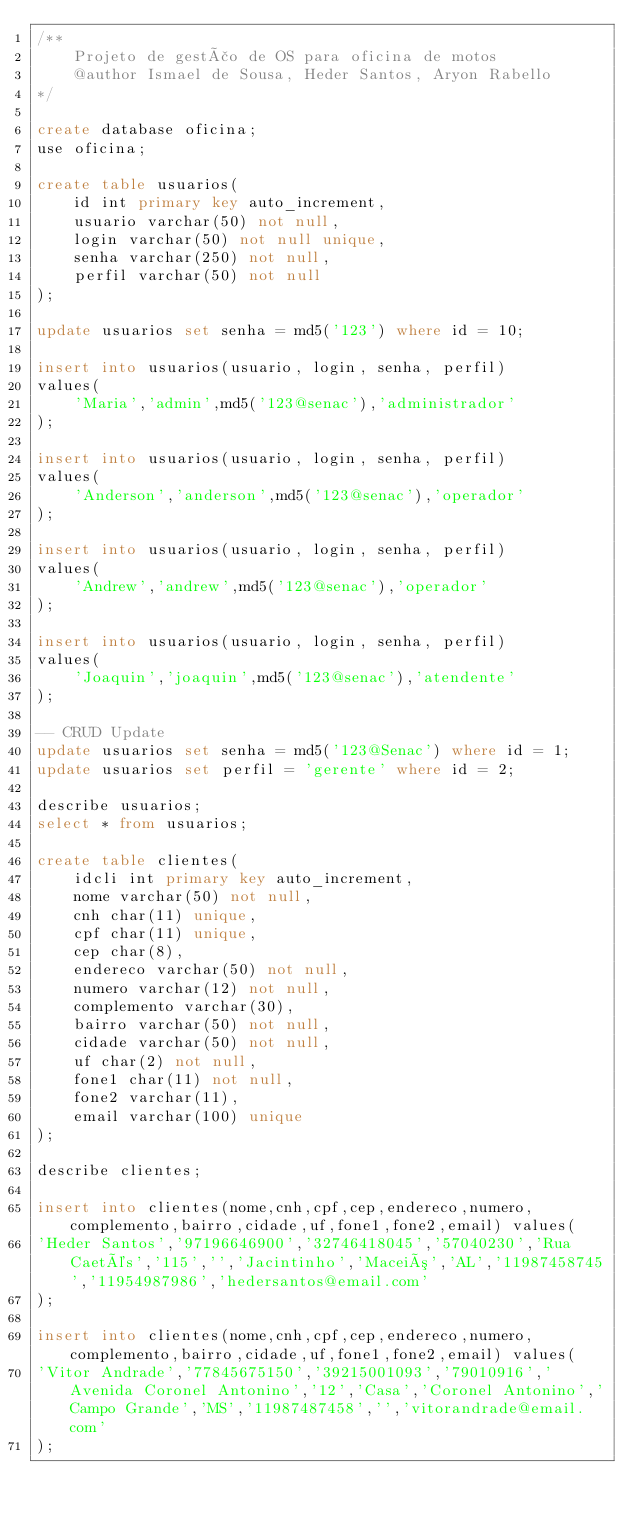Convert code to text. <code><loc_0><loc_0><loc_500><loc_500><_SQL_>/**
	Projeto de gestão de OS para oficina de motos
    @author Ismael de Sousa, Heder Santos, Aryon Rabello
*/

create database oficina;
use oficina;

create table usuarios(
	id int primary key auto_increment,
    usuario varchar(50) not null,
    login varchar(50) not null unique,
    senha varchar(250) not null,
    perfil varchar(50) not null
);

update usuarios set senha = md5('123') where id = 10;

insert into usuarios(usuario, login, senha, perfil)
values(
	'Maria','admin',md5('123@senac'),'administrador'
);

insert into usuarios(usuario, login, senha, perfil)
values(
	'Anderson','anderson',md5('123@senac'),'operador'
);

insert into usuarios(usuario, login, senha, perfil)
values(
	'Andrew','andrew',md5('123@senac'),'operador'
);

insert into usuarios(usuario, login, senha, perfil)
values(
	'Joaquin','joaquin',md5('123@senac'),'atendente'
);

-- CRUD Update
update usuarios set senha = md5('123@Senac') where id = 1; 
update usuarios set perfil = 'gerente' where id = 2;

describe usuarios;
select * from usuarios;

create table clientes(
	idcli int primary key auto_increment,
    nome varchar(50) not null,
    cnh char(11) unique,
    cpf char(11) unique,
    cep char(8),
    endereco varchar(50) not null,
    numero varchar(12) not null,
    complemento varchar(30),
    bairro varchar(50) not null,
    cidade varchar(50) not null,
    uf char(2) not null,
    fone1 char(11) not null,
    fone2 varchar(11),
    email varchar(100) unique
);

describe clientes;

insert into clientes(nome,cnh,cpf,cep,endereco,numero,complemento,bairro,cidade,uf,fone1,fone2,email) values(
'Heder Santos','97196646900','32746418045','57040230','Rua Caetés','115','','Jacintinho','Maceió','AL','11987458745','11954987986','hedersantos@email.com'
);

insert into clientes(nome,cnh,cpf,cep,endereco,numero,complemento,bairro,cidade,uf,fone1,fone2,email) values(
'Vitor Andrade','77845675150','39215001093','79010916','Avenida Coronel Antonino','12','Casa','Coronel Antonino','Campo Grande','MS','11987487458','','vitorandrade@email.com'
);
</code> 